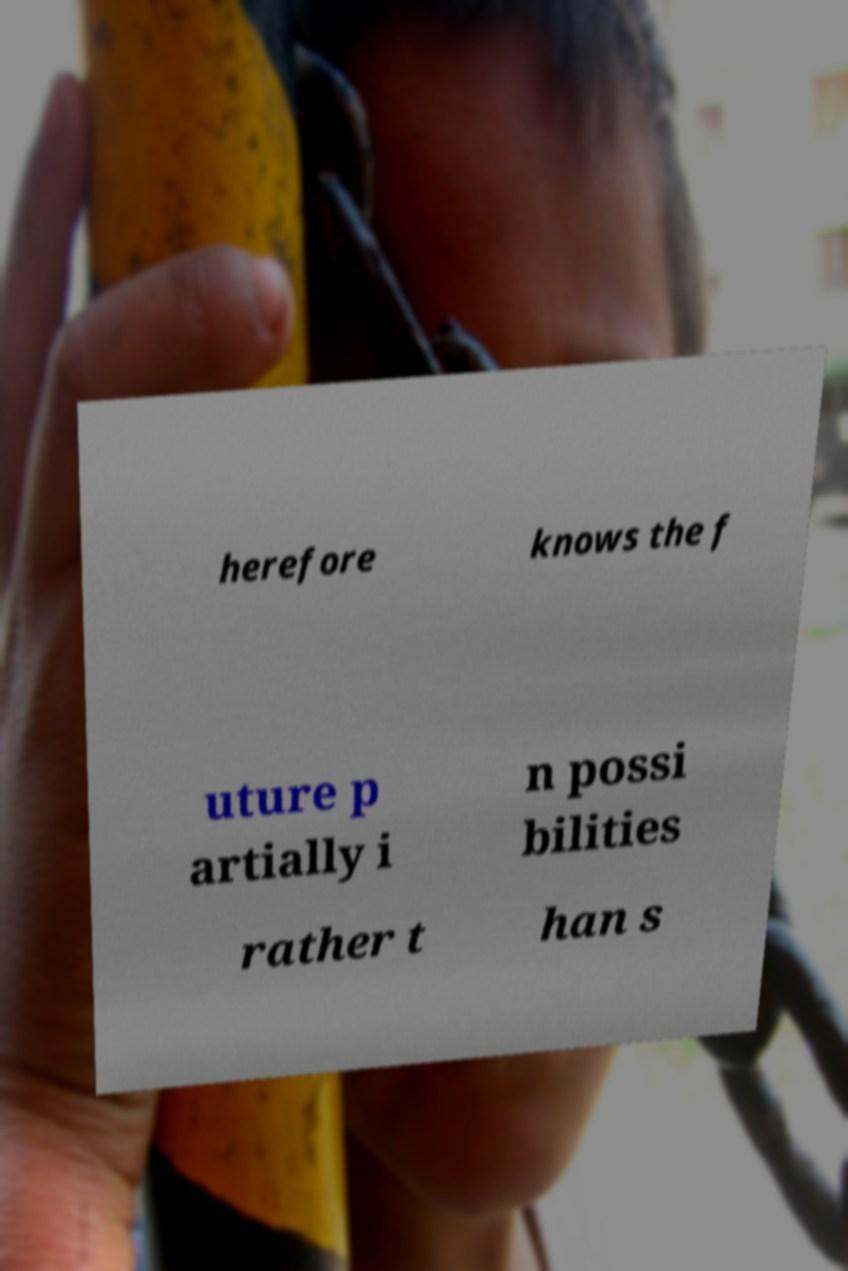Could you extract and type out the text from this image? herefore knows the f uture p artially i n possi bilities rather t han s 